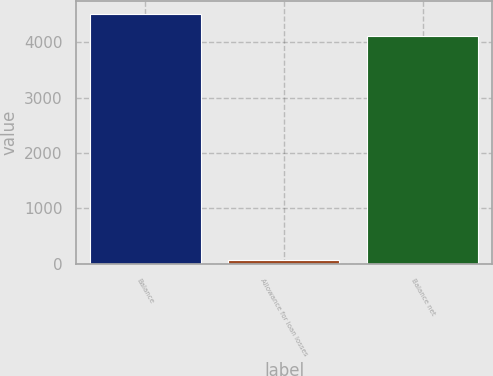Convert chart. <chart><loc_0><loc_0><loc_500><loc_500><bar_chart><fcel>Balance<fcel>Allowance for loan losses<fcel>Balance net<nl><fcel>4518.8<fcel>77<fcel>4108<nl></chart> 